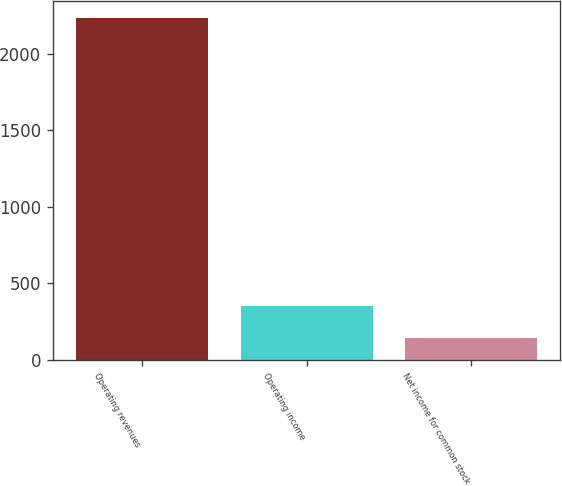Convert chart to OTSL. <chart><loc_0><loc_0><loc_500><loc_500><bar_chart><fcel>Operating revenues<fcel>Operating income<fcel>Net income for common stock<nl><fcel>2236<fcel>348.7<fcel>139<nl></chart> 